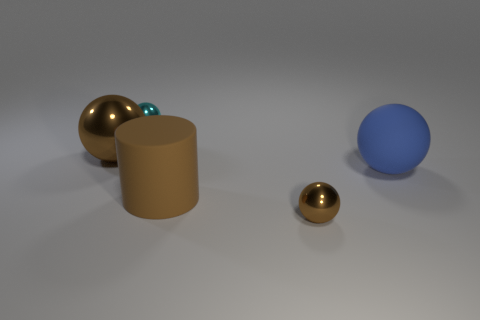Add 5 big metallic objects. How many big metallic objects are left? 6 Add 1 large brown cylinders. How many large brown cylinders exist? 2 Add 2 large cylinders. How many objects exist? 7 Subtract all cyan spheres. How many spheres are left? 3 Subtract all matte spheres. How many spheres are left? 3 Subtract 0 yellow blocks. How many objects are left? 5 Subtract all balls. How many objects are left? 1 Subtract 2 spheres. How many spheres are left? 2 Subtract all cyan balls. Subtract all blue cylinders. How many balls are left? 3 Subtract all blue blocks. How many cyan cylinders are left? 0 